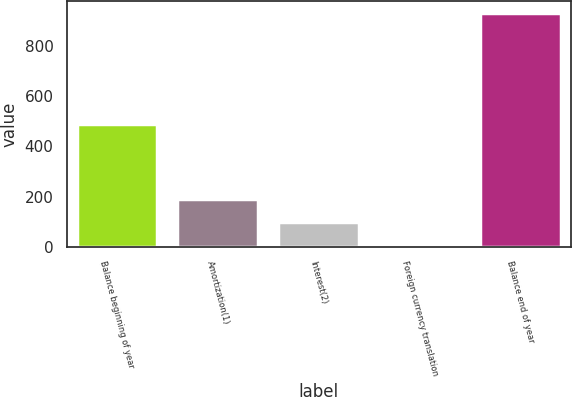Convert chart. <chart><loc_0><loc_0><loc_500><loc_500><bar_chart><fcel>Balance beginning of year<fcel>Amortization(1)<fcel>Interest(2)<fcel>Foreign currency translation<fcel>Balance end of year<nl><fcel>489<fcel>190<fcel>97.5<fcel>5<fcel>930<nl></chart> 